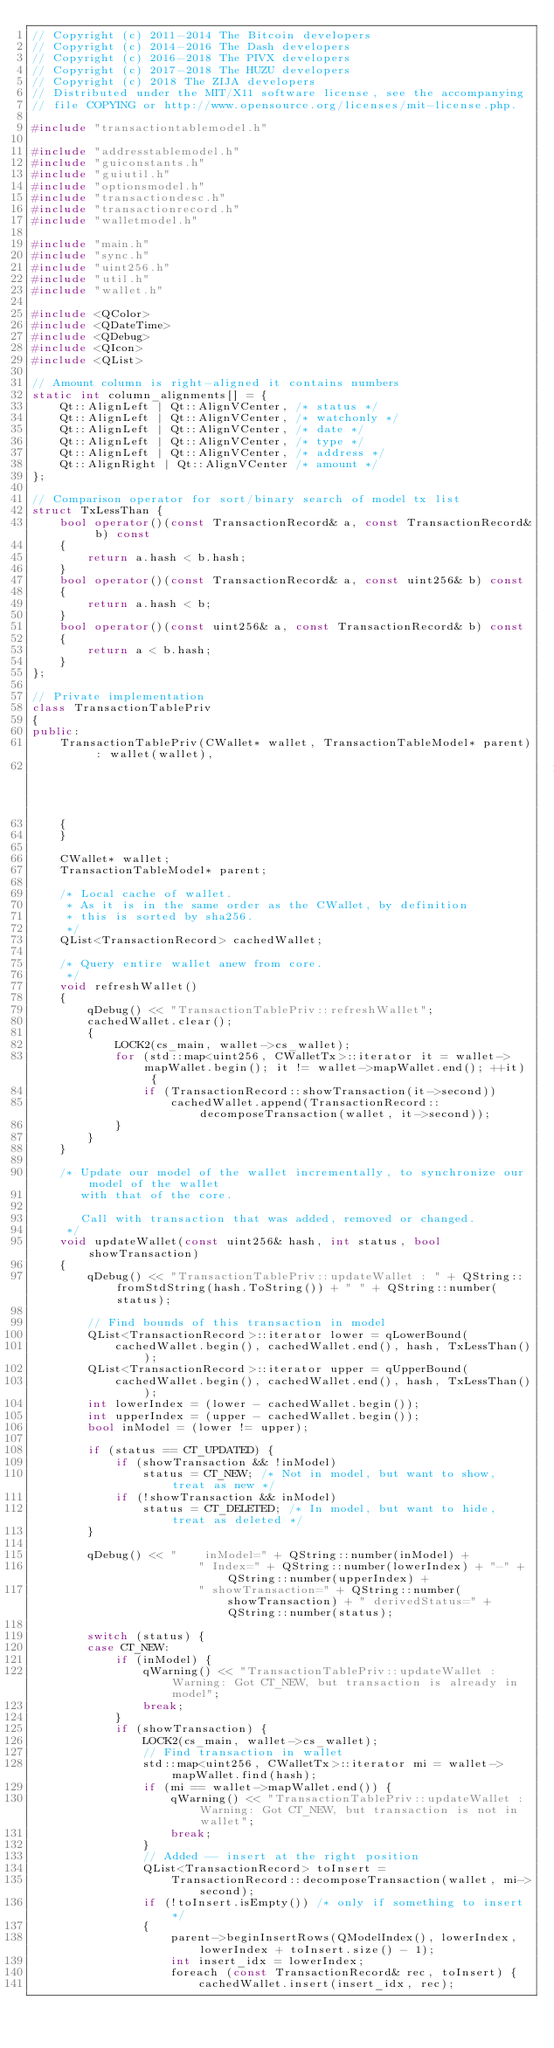<code> <loc_0><loc_0><loc_500><loc_500><_C++_>// Copyright (c) 2011-2014 The Bitcoin developers
// Copyright (c) 2014-2016 The Dash developers
// Copyright (c) 2016-2018 The PIVX developers
// Copyright (c) 2017-2018 The HUZU developers
// Copyright (c) 2018 The ZIJA developers
// Distributed under the MIT/X11 software license, see the accompanying
// file COPYING or http://www.opensource.org/licenses/mit-license.php.

#include "transactiontablemodel.h"

#include "addresstablemodel.h"
#include "guiconstants.h"
#include "guiutil.h"
#include "optionsmodel.h"
#include "transactiondesc.h"
#include "transactionrecord.h"
#include "walletmodel.h"

#include "main.h"
#include "sync.h"
#include "uint256.h"
#include "util.h"
#include "wallet.h"

#include <QColor>
#include <QDateTime>
#include <QDebug>
#include <QIcon>
#include <QList>

// Amount column is right-aligned it contains numbers
static int column_alignments[] = {
    Qt::AlignLeft | Qt::AlignVCenter, /* status */
    Qt::AlignLeft | Qt::AlignVCenter, /* watchonly */
    Qt::AlignLeft | Qt::AlignVCenter, /* date */
    Qt::AlignLeft | Qt::AlignVCenter, /* type */
    Qt::AlignLeft | Qt::AlignVCenter, /* address */
    Qt::AlignRight | Qt::AlignVCenter /* amount */
};

// Comparison operator for sort/binary search of model tx list
struct TxLessThan {
    bool operator()(const TransactionRecord& a, const TransactionRecord& b) const
    {
        return a.hash < b.hash;
    }
    bool operator()(const TransactionRecord& a, const uint256& b) const
    {
        return a.hash < b;
    }
    bool operator()(const uint256& a, const TransactionRecord& b) const
    {
        return a < b.hash;
    }
};

// Private implementation
class TransactionTablePriv
{
public:
    TransactionTablePriv(CWallet* wallet, TransactionTableModel* parent) : wallet(wallet),
                                                                           parent(parent)
    {
    }

    CWallet* wallet;
    TransactionTableModel* parent;

    /* Local cache of wallet.
     * As it is in the same order as the CWallet, by definition
     * this is sorted by sha256.
     */
    QList<TransactionRecord> cachedWallet;

    /* Query entire wallet anew from core.
     */
    void refreshWallet()
    {
        qDebug() << "TransactionTablePriv::refreshWallet";
        cachedWallet.clear();
        {
            LOCK2(cs_main, wallet->cs_wallet);
            for (std::map<uint256, CWalletTx>::iterator it = wallet->mapWallet.begin(); it != wallet->mapWallet.end(); ++it) {
                if (TransactionRecord::showTransaction(it->second))
                    cachedWallet.append(TransactionRecord::decomposeTransaction(wallet, it->second));
            }
        }
    }

    /* Update our model of the wallet incrementally, to synchronize our model of the wallet
       with that of the core.

       Call with transaction that was added, removed or changed.
     */
    void updateWallet(const uint256& hash, int status, bool showTransaction)
    {
        qDebug() << "TransactionTablePriv::updateWallet : " + QString::fromStdString(hash.ToString()) + " " + QString::number(status);

        // Find bounds of this transaction in model
        QList<TransactionRecord>::iterator lower = qLowerBound(
            cachedWallet.begin(), cachedWallet.end(), hash, TxLessThan());
        QList<TransactionRecord>::iterator upper = qUpperBound(
            cachedWallet.begin(), cachedWallet.end(), hash, TxLessThan());
        int lowerIndex = (lower - cachedWallet.begin());
        int upperIndex = (upper - cachedWallet.begin());
        bool inModel = (lower != upper);

        if (status == CT_UPDATED) {
            if (showTransaction && !inModel)
                status = CT_NEW; /* Not in model, but want to show, treat as new */
            if (!showTransaction && inModel)
                status = CT_DELETED; /* In model, but want to hide, treat as deleted */
        }

        qDebug() << "    inModel=" + QString::number(inModel) +
                        " Index=" + QString::number(lowerIndex) + "-" + QString::number(upperIndex) +
                        " showTransaction=" + QString::number(showTransaction) + " derivedStatus=" + QString::number(status);

        switch (status) {
        case CT_NEW:
            if (inModel) {
                qWarning() << "TransactionTablePriv::updateWallet : Warning: Got CT_NEW, but transaction is already in model";
                break;
            }
            if (showTransaction) {
                LOCK2(cs_main, wallet->cs_wallet);
                // Find transaction in wallet
                std::map<uint256, CWalletTx>::iterator mi = wallet->mapWallet.find(hash);
                if (mi == wallet->mapWallet.end()) {
                    qWarning() << "TransactionTablePriv::updateWallet : Warning: Got CT_NEW, but transaction is not in wallet";
                    break;
                }
                // Added -- insert at the right position
                QList<TransactionRecord> toInsert =
                    TransactionRecord::decomposeTransaction(wallet, mi->second);
                if (!toInsert.isEmpty()) /* only if something to insert */
                {
                    parent->beginInsertRows(QModelIndex(), lowerIndex, lowerIndex + toInsert.size() - 1);
                    int insert_idx = lowerIndex;
                    foreach (const TransactionRecord& rec, toInsert) {
                        cachedWallet.insert(insert_idx, rec);</code> 